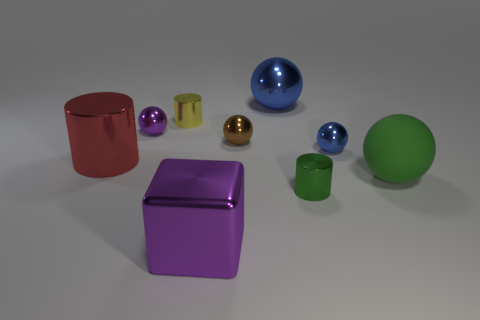Subtract all large metal cylinders. How many cylinders are left? 2 Add 1 small blue objects. How many objects exist? 10 Subtract all yellow cylinders. How many cylinders are left? 2 Subtract all brown cylinders. How many brown spheres are left? 1 Subtract 0 cyan blocks. How many objects are left? 9 Subtract all cubes. How many objects are left? 8 Subtract 5 spheres. How many spheres are left? 0 Subtract all cyan spheres. Subtract all cyan blocks. How many spheres are left? 5 Subtract all metallic cylinders. Subtract all tiny cyan blocks. How many objects are left? 6 Add 4 purple shiny cubes. How many purple shiny cubes are left? 5 